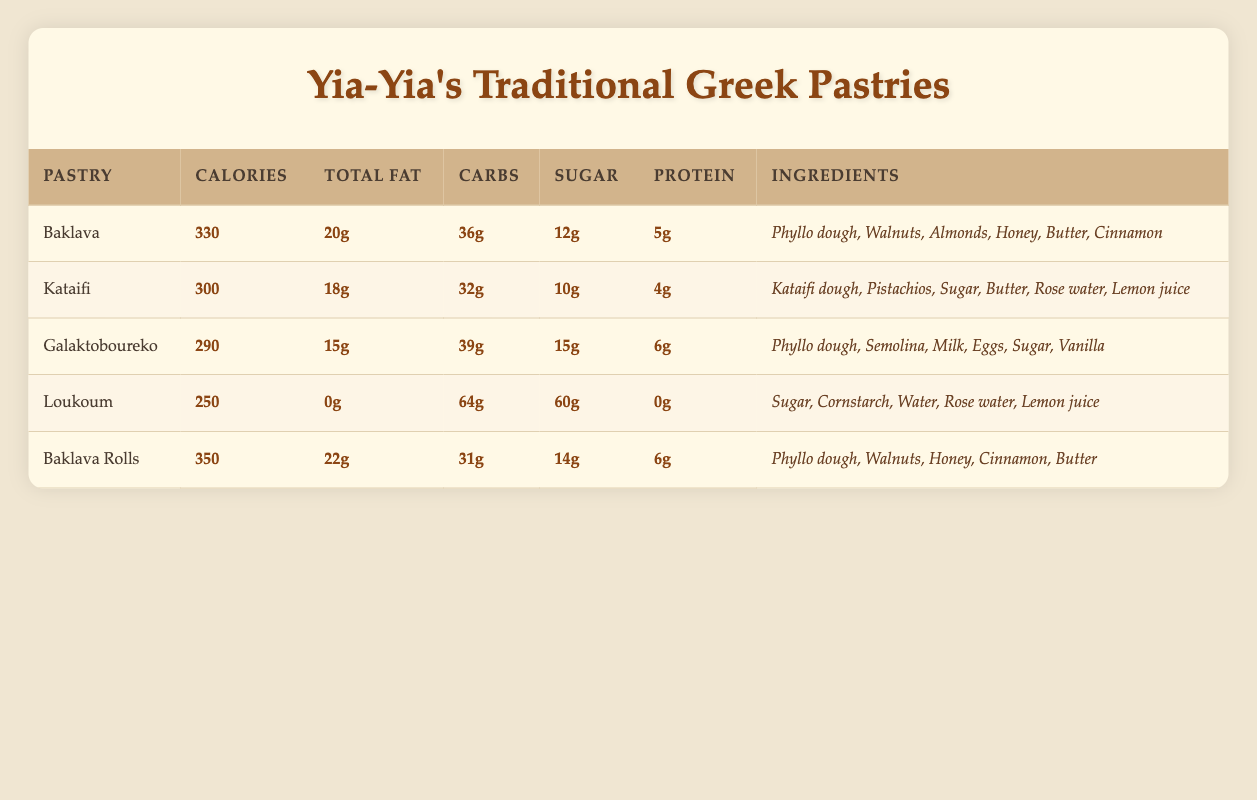What is the total fat content in Galaktoboureko? The table shows that Galaktoboureko has a total fat content of 15g. Therefore, I simply looked at the total fat column next to the name Galaktoboureko.
Answer: 15g Which pastry has the highest protein content? By examining the protein values in the table, I see that both Galaktoboureko and Baklava Rolls have the highest protein content of 6g. I looked at the protein column for both pastries to ascertain this.
Answer: Galaktoboureko and Baklava Rolls with 6g How many grams of sugar does Loukoum have? The table indicates that Loukoum has 60g of sugar listed alongside its name in the sugar column. There is no calculation needed here, just a straightforward retrieval of the value.
Answer: 60g What is the average calorie count of the pastries? To calculate the average calorie count, I added the calorie amounts from each pastry (330 + 300 + 290 + 250 + 350 = 1520), then I divided by the number of pastries (5), resulting in an average of 1520/5, which equals 304.
Answer: 304 Does Baklava contain almonds? By checking the ingredients listed for Baklava, I see that it contains almonds. The ingredient list for Baklava includes "Walnuts," "Almonds," "Honey," "Butter," "Cinnamon," and "Phyllo dough." Therefore, the answer is yes.
Answer: Yes Which pastry has the least carbohydrates? Looking at the carbohydrates column, I find that Baklava Rolls has 31g of carbohydrates, while Loukoum has 64g, and other pastries have more than that. Thus, Baklava Rolls has the least carbohydrates at 31g.
Answer: Baklava Rolls with 31g What is the total fat difference between Kataifi and Baklava? I subtract the total fat content of Kataifi (18g) from that of Baklava (20g). The difference is calculated as 20g - 18g = 2g. Therefore, there is a difference of 2g in total fat.
Answer: 2g How many pastries have more than 300 calories? By reviewing the calorie counts, I find that Baklava (330g), Baklava Rolls (350g) exceed 300 calories. So, there are 3 pastries that meet this criterion (Baklava, Baklava Rolls, and Kataifi).
Answer: 3 What ingredient appears in both Baklava and Baklava Rolls? Inspecting both ingredients lists, I notice that both Baklava and Baklava Rolls contain "Phyllo dough," "Walnuts," and "Honey." Therefore, there are three common ingredients.
Answer: Phyllo dough, Walnuts, Honey 